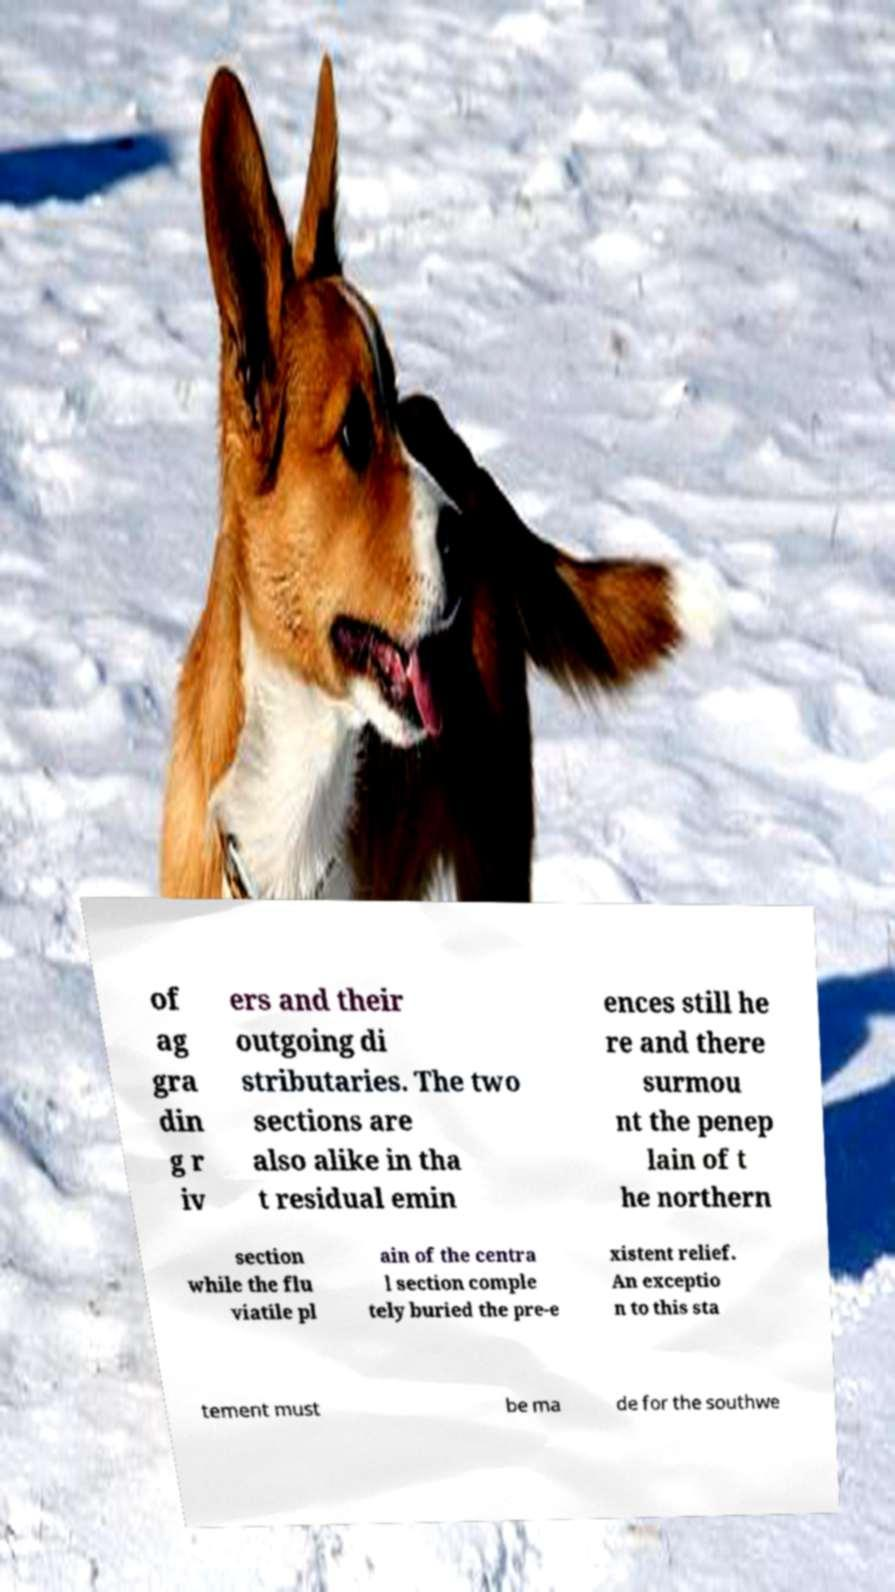Could you extract and type out the text from this image? of ag gra din g r iv ers and their outgoing di stributaries. The two sections are also alike in tha t residual emin ences still he re and there surmou nt the penep lain of t he northern section while the flu viatile pl ain of the centra l section comple tely buried the pre-e xistent relief. An exceptio n to this sta tement must be ma de for the southwe 